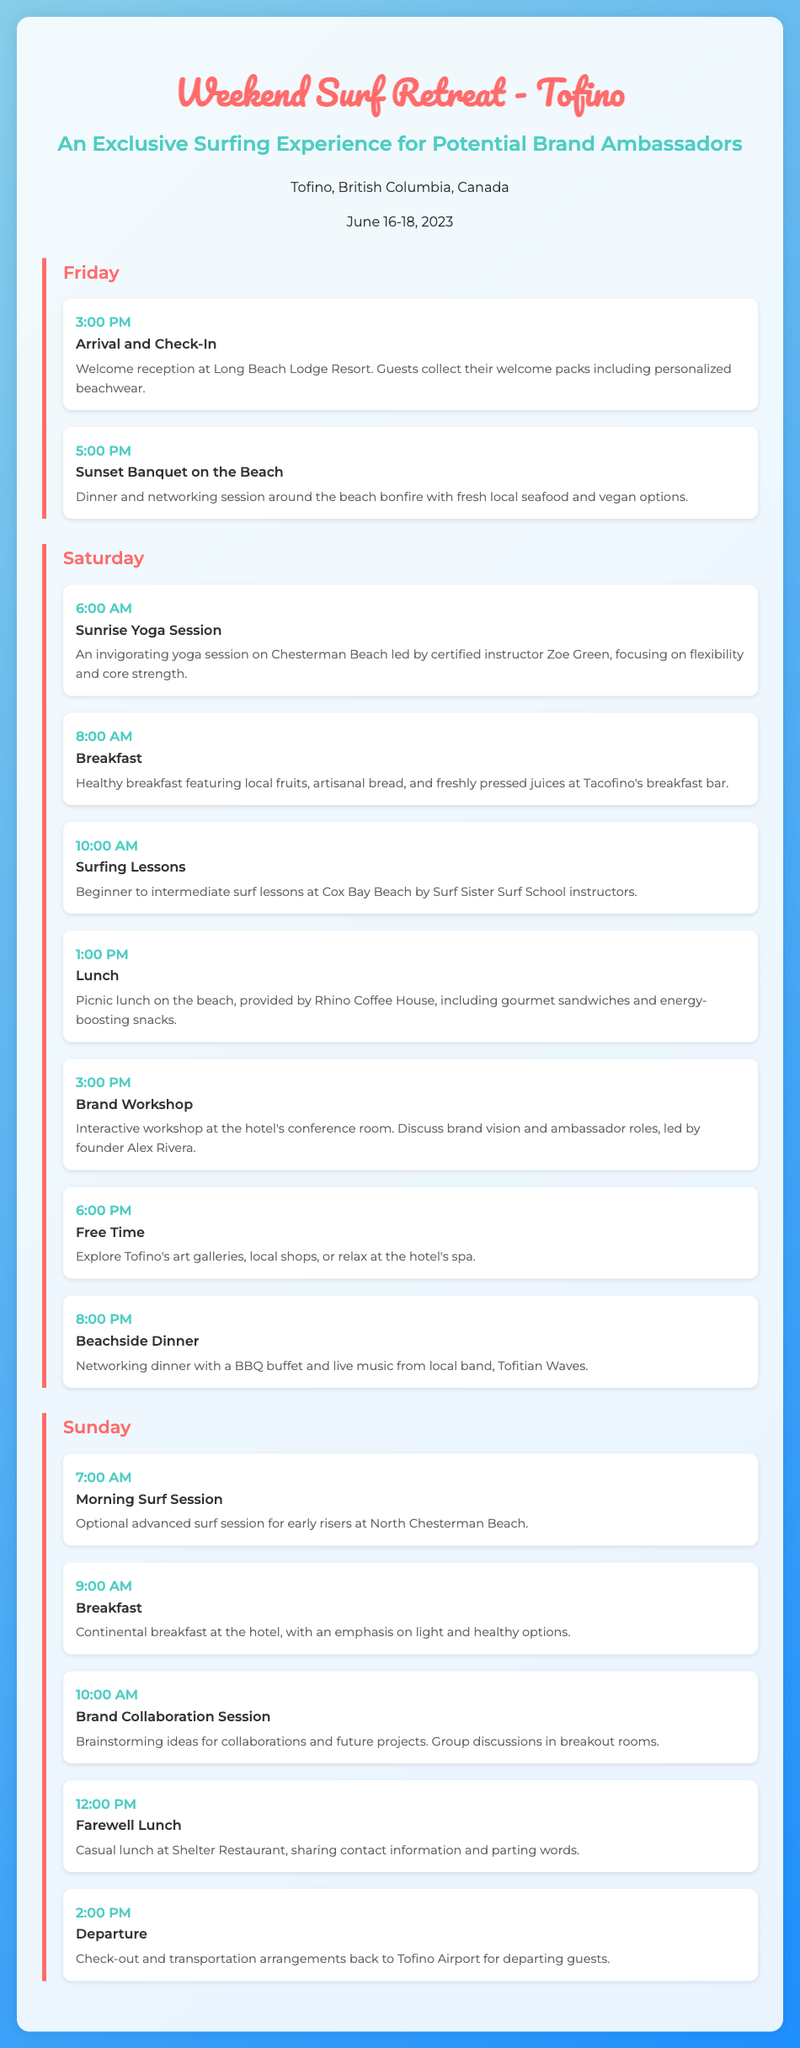What is the location of the retreat? The document states that the location of the retreat is Tofino, British Columbia, Canada.
Answer: Tofino, British Columbia, Canada What is the date of the retreat? The retreat is scheduled from June 16-18, 2023, as indicated in the document.
Answer: June 16-18, 2023 What time does the arrival and check-in begin? The arrival and check-in is scheduled for 3:00 PM on Friday according to the itinerary.
Answer: 3:00 PM Who leads the sunrise yoga session? The document mentions that the sunrise yoga session is led by certified instructor Zoe Green.
Answer: Zoe Green What type of accommodation is provided on arrival? Guests collect their welcome packs including personalized beachwear, as per the event details at check-in.
Answer: Personalized beachwear What activity is scheduled for Saturday at 10:00 AM? Surfing lessons for beginner to intermediate levels are scheduled at this time.
Answer: Surfing Lessons What is served at the sunset banquet? The sunset banquet features fresh local seafood and vegan options, as described in the event details.
Answer: Fresh local seafood and vegan options What type of session is scheduled on Sunday at 10:00 AM? There is a brand collaboration session where brainstorming ideas for collaborations and future projects will take place.
Answer: Brand Collaboration Session What is the farewell lunch venue? The farewell lunch is scheduled at Shelter Restaurant, as indicated in the event details.
Answer: Shelter Restaurant 